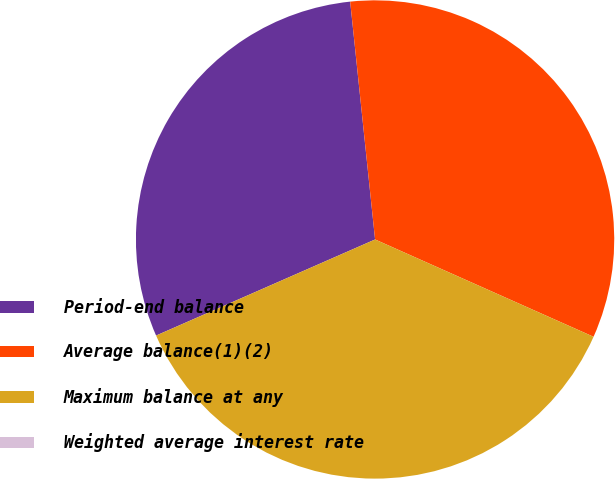Convert chart. <chart><loc_0><loc_0><loc_500><loc_500><pie_chart><fcel>Period-end balance<fcel>Average balance(1)(2)<fcel>Maximum balance at any<fcel>Weighted average interest rate<nl><fcel>29.92%<fcel>33.33%<fcel>36.75%<fcel>0.0%<nl></chart> 